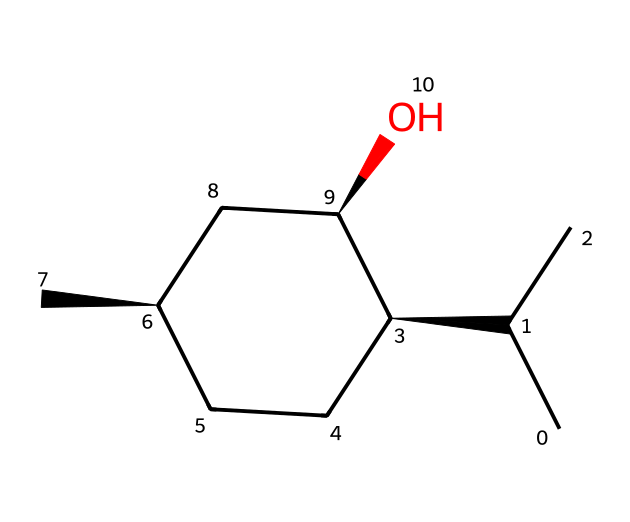What is the chemical name of this compound? The provided SMILES corresponds to menthol, which is a common compound used for its cooling effects. The structure indicates a specific arrangement of carbon atoms, a hydroxyl group, and chiral centers leading to menthol.
Answer: menthol How many chiral centers does menthol have? By examining the structure, we see that there are three chiral centers, indicated by the stereochemistry at the specified carbon atoms in the SMILES representation.
Answer: three How many carbon atoms are in the menthol structure? Counting the carbon atoms in the SMILES representation reveals that there are ten carbon atoms present in the structure of menthol.
Answer: ten What functional group is present in menthol? The presence of the hydroxyl group (-OH) in the structure indicates that menthol has an alcohol functional group. This characteristic is vital for its cooling properties.
Answer: alcohol What is the major application of menthol? Menthol is primarily used for its cooling properties in muscle rubs and topical analgesics, providing relief to athletes and others experiencing discomfort.
Answer: muscle rubs Which property allows menthol to act as a cooling agent? The spatial arrangement of atoms, particularly the hydroxy group contributing to its interaction with sensory receptors, enables menthol to create a cooling sensation when applied to the skin.
Answer: chiral composition 